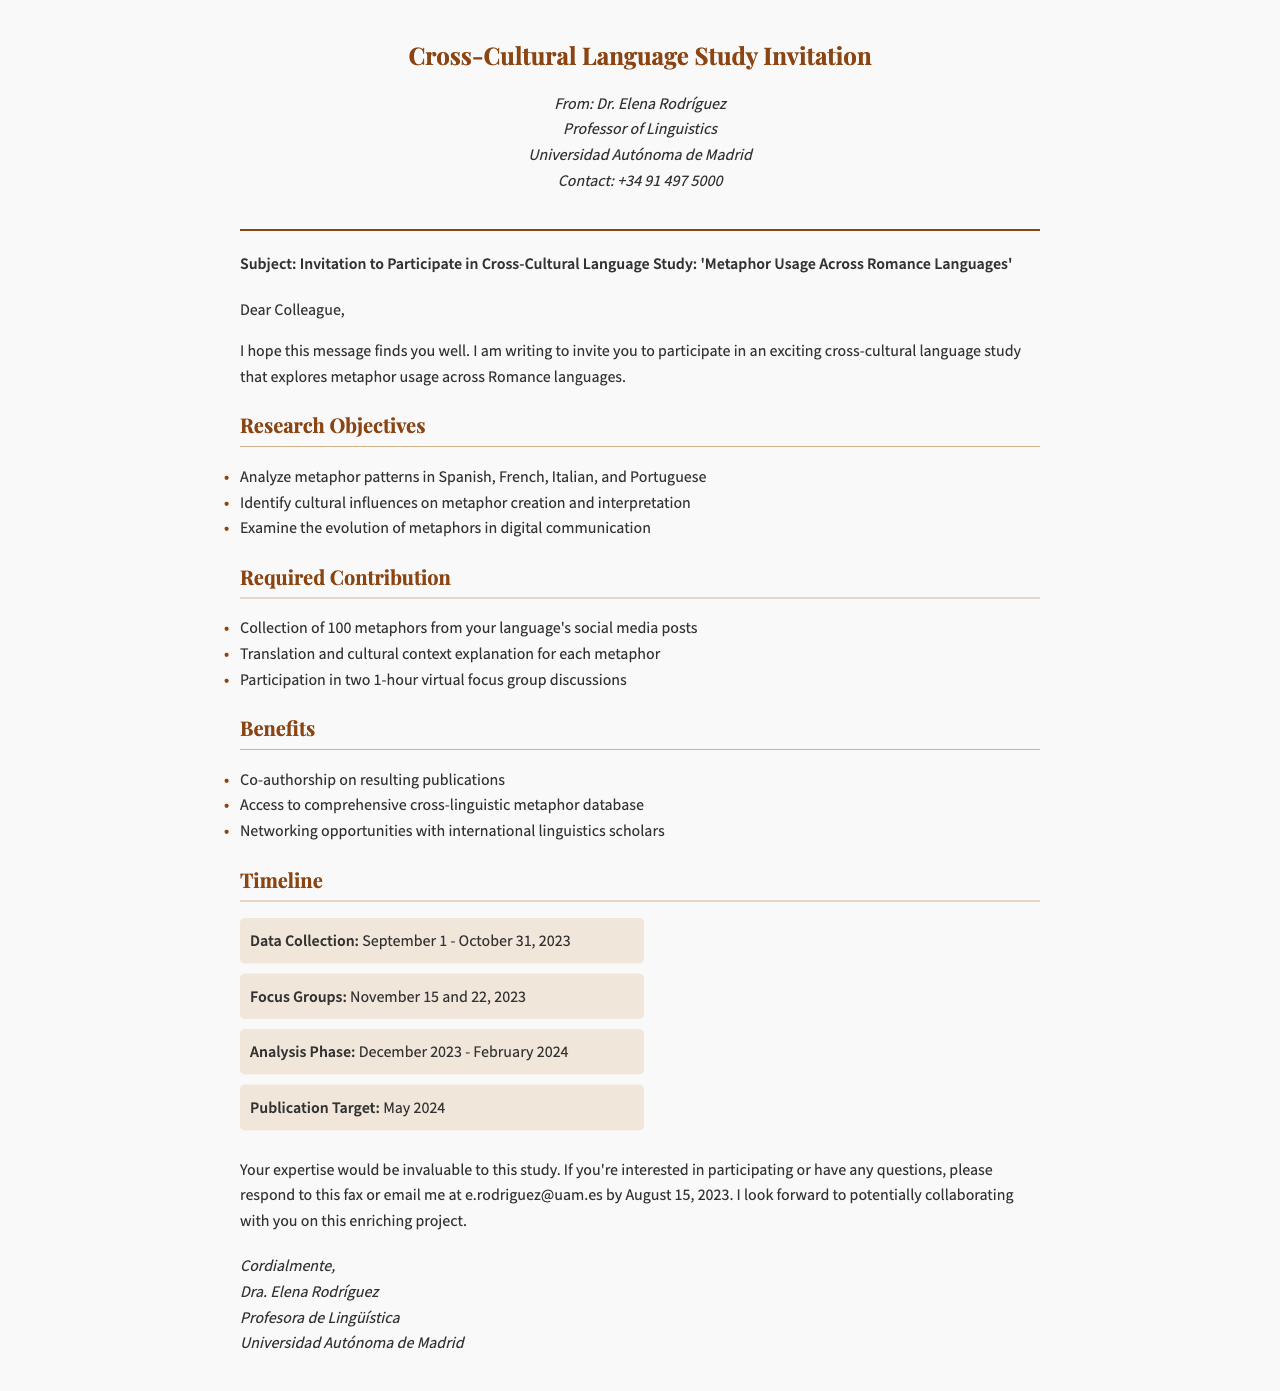What is the title of the study? The title is the subject of the fax which describes the focus of the research.
Answer: Metaphor Usage Across Romance Languages Who is the sender of the fax? The sender's details are found at the top of the fax, stating her name and title.
Answer: Dr. Elena Rodríguez What is the deadline for response? The deadline is mentioned towards the end of the document, indicating when to reply by.
Answer: August 15, 2023 What languages are included in the study? The document lists the languages being analyzed in the research objectives section.
Answer: Spanish, French, Italian, and Portuguese How many metaphors need to be collected? This information is specified in the required contributions of the study.
Answer: 100 What is the publication target date? This date is provided in the timeline section of the document, indicating when the findings are expected to be published.
Answer: May 2024 What format will the study data be collected from? This detail explains the specific platform or source for gathering metaphors, as stated in the required contribution section.
Answer: Social media posts How long will the focus group discussions last? The duration of the discussions is mentioned as part of the required contributions.
Answer: 1 hour What will participants receive for their contribution? This refers to the benefits section, detailing what participants will gain from joining the study.
Answer: Co-authorship on resulting publications 